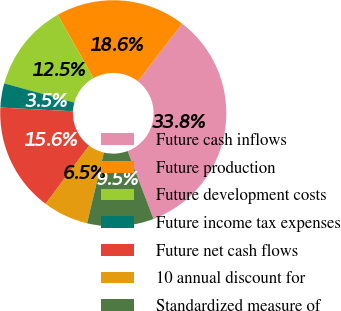Convert chart. <chart><loc_0><loc_0><loc_500><loc_500><pie_chart><fcel>Future cash inflows<fcel>Future production<fcel>Future development costs<fcel>Future income tax expenses<fcel>Future net cash flows<fcel>10 annual discount for<fcel>Standardized measure of<nl><fcel>33.78%<fcel>18.62%<fcel>12.55%<fcel>3.46%<fcel>15.59%<fcel>6.49%<fcel>9.52%<nl></chart> 